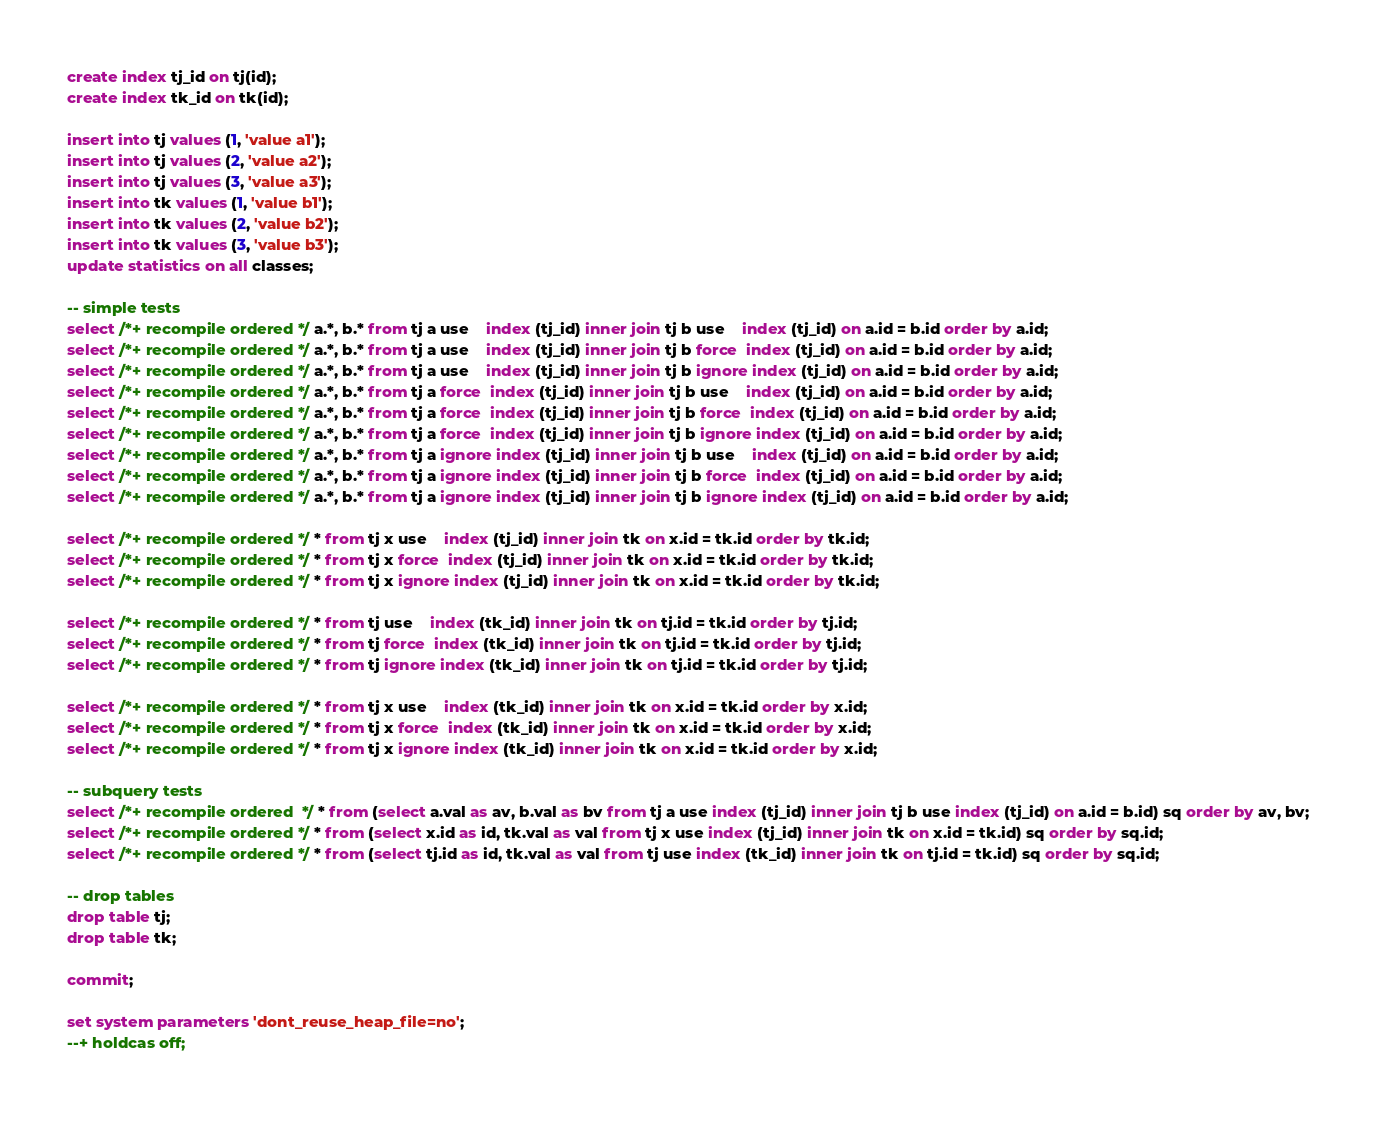Convert code to text. <code><loc_0><loc_0><loc_500><loc_500><_SQL_>
create index tj_id on tj(id);
create index tk_id on tk(id);

insert into tj values (1, 'value a1');
insert into tj values (2, 'value a2');
insert into tj values (3, 'value a3');
insert into tk values (1, 'value b1');
insert into tk values (2, 'value b2');
insert into tk values (3, 'value b3');
update statistics on all classes;

-- simple tests
select /*+ recompile ordered */ a.*, b.* from tj a use    index (tj_id) inner join tj b use    index (tj_id) on a.id = b.id order by a.id;
select /*+ recompile ordered */ a.*, b.* from tj a use    index (tj_id) inner join tj b force  index (tj_id) on a.id = b.id order by a.id;
select /*+ recompile ordered */ a.*, b.* from tj a use    index (tj_id) inner join tj b ignore index (tj_id) on a.id = b.id order by a.id;
select /*+ recompile ordered */ a.*, b.* from tj a force  index (tj_id) inner join tj b use    index (tj_id) on a.id = b.id order by a.id;
select /*+ recompile ordered */ a.*, b.* from tj a force  index (tj_id) inner join tj b force  index (tj_id) on a.id = b.id order by a.id;
select /*+ recompile ordered */ a.*, b.* from tj a force  index (tj_id) inner join tj b ignore index (tj_id) on a.id = b.id order by a.id;
select /*+ recompile ordered */ a.*, b.* from tj a ignore index (tj_id) inner join tj b use    index (tj_id) on a.id = b.id order by a.id;
select /*+ recompile ordered */ a.*, b.* from tj a ignore index (tj_id) inner join tj b force  index (tj_id) on a.id = b.id order by a.id;
select /*+ recompile ordered */ a.*, b.* from tj a ignore index (tj_id) inner join tj b ignore index (tj_id) on a.id = b.id order by a.id;

select /*+ recompile ordered */ * from tj x use    index (tj_id) inner join tk on x.id = tk.id order by tk.id;
select /*+ recompile ordered */ * from tj x force  index (tj_id) inner join tk on x.id = tk.id order by tk.id;
select /*+ recompile ordered */ * from tj x ignore index (tj_id) inner join tk on x.id = tk.id order by tk.id;

select /*+ recompile ordered */ * from tj use    index (tk_id) inner join tk on tj.id = tk.id order by tj.id;
select /*+ recompile ordered */ * from tj force  index (tk_id) inner join tk on tj.id = tk.id order by tj.id;
select /*+ recompile ordered */ * from tj ignore index (tk_id) inner join tk on tj.id = tk.id order by tj.id;

select /*+ recompile ordered */ * from tj x use    index (tk_id) inner join tk on x.id = tk.id order by x.id;
select /*+ recompile ordered */ * from tj x force  index (tk_id) inner join tk on x.id = tk.id order by x.id;
select /*+ recompile ordered */ * from tj x ignore index (tk_id) inner join tk on x.id = tk.id order by x.id;

-- subquery tests
select /*+ recompile ordered  */ * from (select a.val as av, b.val as bv from tj a use index (tj_id) inner join tj b use index (tj_id) on a.id = b.id) sq order by av, bv;
select /*+ recompile ordered */ * from (select x.id as id, tk.val as val from tj x use index (tj_id) inner join tk on x.id = tk.id) sq order by sq.id;
select /*+ recompile ordered */ * from (select tj.id as id, tk.val as val from tj use index (tk_id) inner join tk on tj.id = tk.id) sq order by sq.id;

-- drop tables
drop table tj;
drop table tk;

commit;

set system parameters 'dont_reuse_heap_file=no';
--+ holdcas off;
</code> 